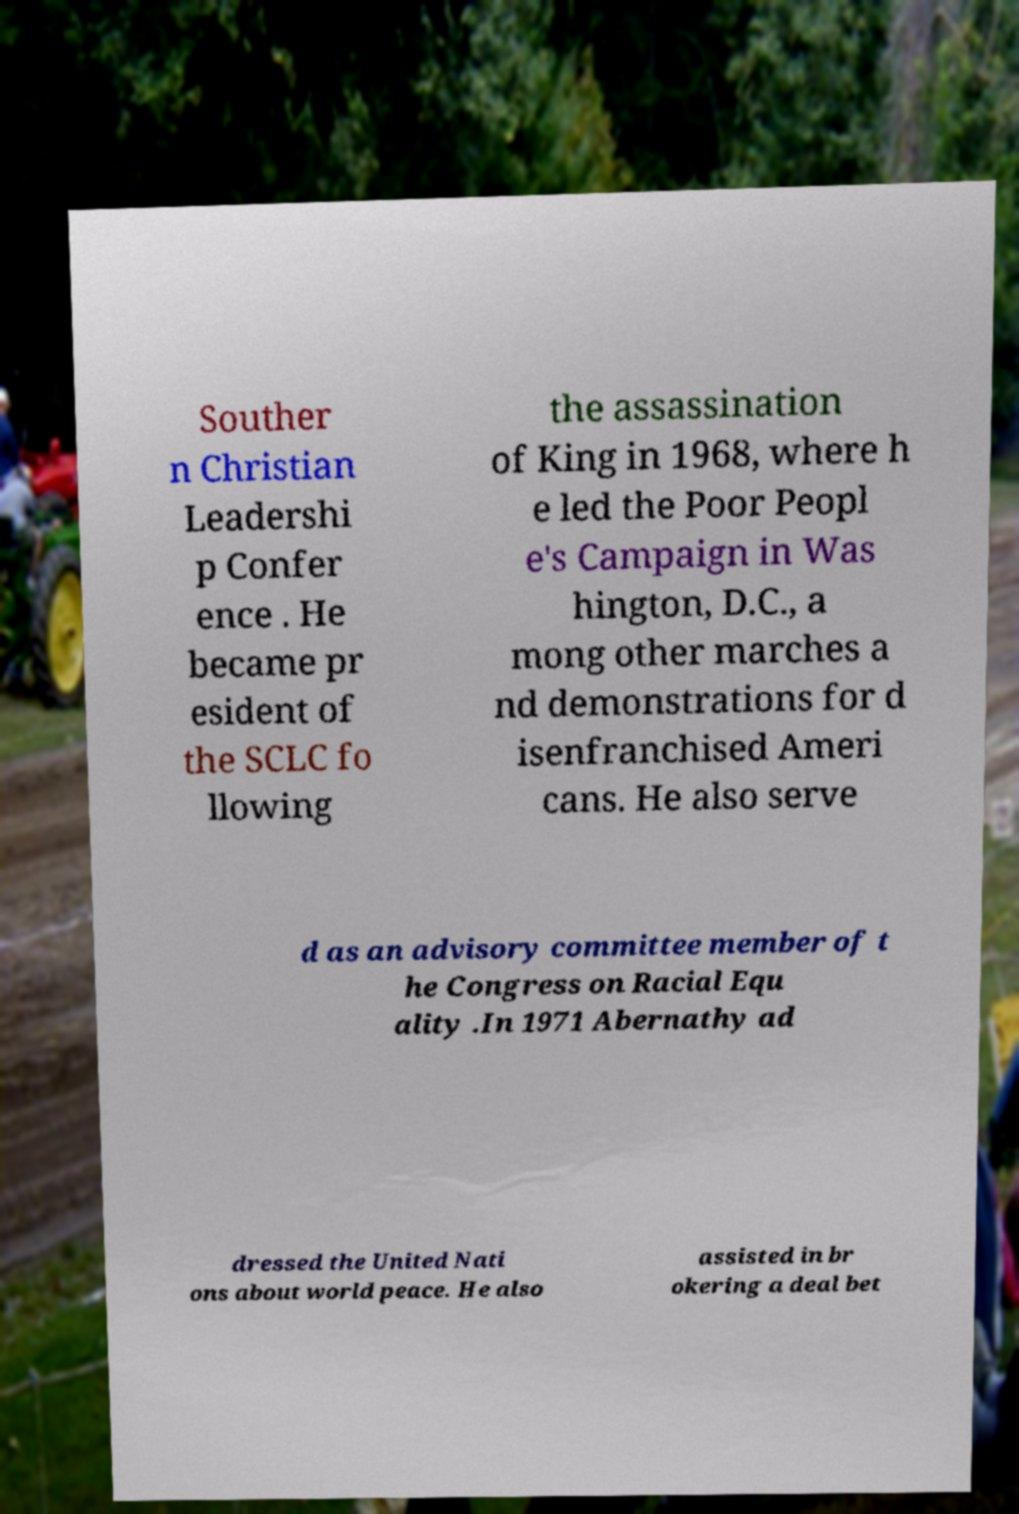There's text embedded in this image that I need extracted. Can you transcribe it verbatim? Souther n Christian Leadershi p Confer ence . He became pr esident of the SCLC fo llowing the assassination of King in 1968, where h e led the Poor Peopl e's Campaign in Was hington, D.C., a mong other marches a nd demonstrations for d isenfranchised Ameri cans. He also serve d as an advisory committee member of t he Congress on Racial Equ ality .In 1971 Abernathy ad dressed the United Nati ons about world peace. He also assisted in br okering a deal bet 